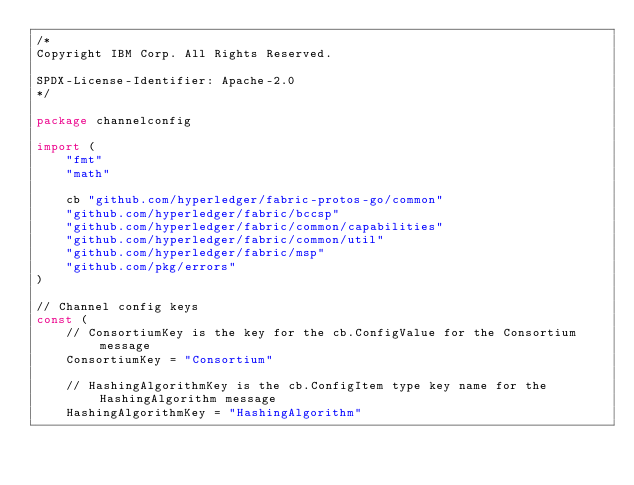Convert code to text. <code><loc_0><loc_0><loc_500><loc_500><_Go_>/*
Copyright IBM Corp. All Rights Reserved.

SPDX-License-Identifier: Apache-2.0
*/

package channelconfig

import (
	"fmt"
	"math"

	cb "github.com/hyperledger/fabric-protos-go/common"
	"github.com/hyperledger/fabric/bccsp"
	"github.com/hyperledger/fabric/common/capabilities"
	"github.com/hyperledger/fabric/common/util"
	"github.com/hyperledger/fabric/msp"
	"github.com/pkg/errors"
)

// Channel config keys
const (
	// ConsortiumKey is the key for the cb.ConfigValue for the Consortium message
	ConsortiumKey = "Consortium"

	// HashingAlgorithmKey is the cb.ConfigItem type key name for the HashingAlgorithm message
	HashingAlgorithmKey = "HashingAlgorithm"
</code> 